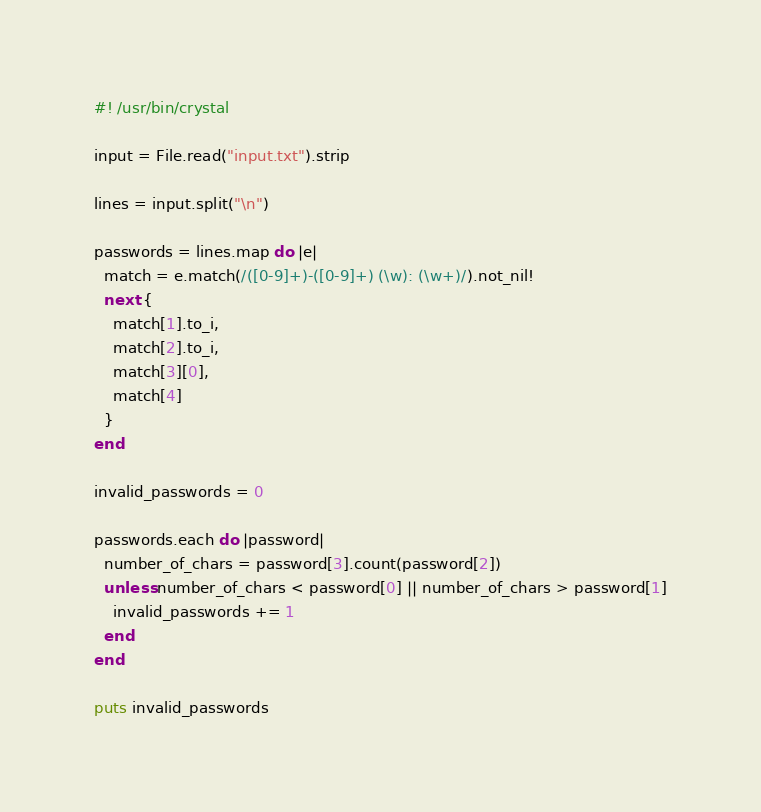Convert code to text. <code><loc_0><loc_0><loc_500><loc_500><_Crystal_>#! /usr/bin/crystal

input = File.read("input.txt").strip

lines = input.split("\n")

passwords = lines.map do |e|
  match = e.match(/([0-9]+)-([0-9]+) (\w): (\w+)/).not_nil!
  next {
    match[1].to_i,
    match[2].to_i,
    match[3][0],
    match[4]
  }
end

invalid_passwords = 0

passwords.each do |password|
  number_of_chars = password[3].count(password[2])
  unless number_of_chars < password[0] || number_of_chars > password[1]
    invalid_passwords += 1
  end
end

puts invalid_passwords
</code> 